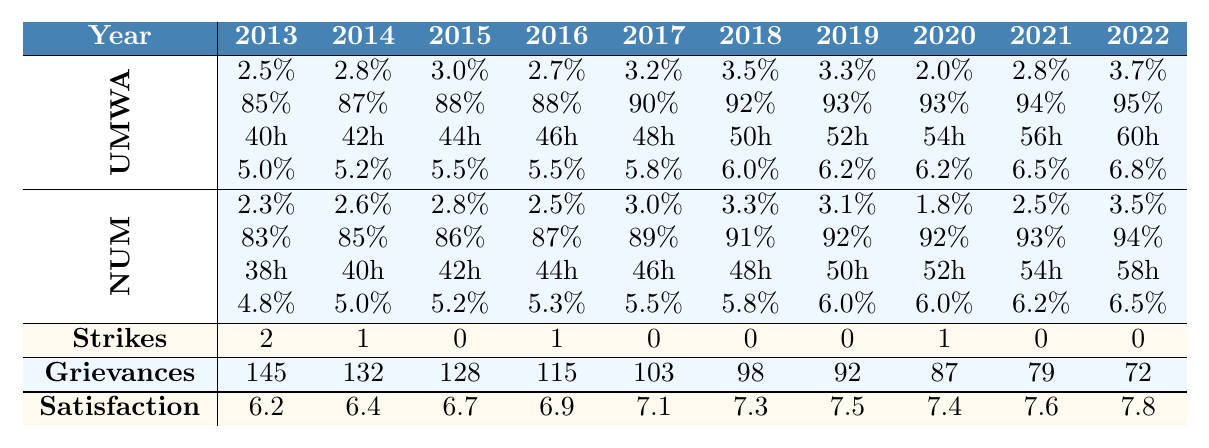What was the highest wage increase percentage from the United Mine Workers of America over the decade? Looking at the UMWA row for "Wage Increase (%)", the highest value appears to be 3.7% in 2022.
Answer: 3.7% How many hours of safety training were implemented in 2015 by the National Union of Mineworkers? The "Safety Training Hours" for NUM in 2015 is listed as 42 hours.
Answer: 42 hours Which year saw the least number of grievances filed? Referring to the "Grievances Filed" row, the least amount is 72 grievances in 2022.
Answer: 72 What is the average wage increase percentage over the decade for the United Mine Workers of America? The wage increase percentages are 2.5, 2.8, 3.0, 2.7, 3.2, 3.5, 3.3, 2.0, 2.8, and 3.7. To find the average, add them all up (28.5) and divide by 10, resulting in 2.85%.
Answer: 2.85% Did the United Mine Workers of America have more wage increases compared to the National Union of Mineworkers from 2013 to 2022? Observing the "Wage Increase (%)" for both unions shows UMWA had higher percentages in most years, with NUM only exceeding UMWA in 2014, 2018, and 2019.
Answer: Yes In which year did the highest worker satisfaction score occur? Looking at the "Worker Satisfaction Score" row, the highest score is 7.8, recorded in 2022.
Answer: 2022 What was the change in healthcare coverage percentage from 2013 to 2022 for the National Union of Mineworkers? The percentage for NUM in 2013 is 83%, and it increased to 94% in 2022. The change is 94% - 83% = 11%.
Answer: 11% How many total strikes occurred from 2013 to 2022? To find the total strikes, add the values from the "Strikes" row: 2 + 1 + 0 + 1 + 0 + 0 + 0 + 1 + 0 + 0, totaling 5 strikes.
Answer: 5 Was there a year without any strikes from the United Mine Workers of America? Checking the "Strikes" row, the years 2015, 2017, 2018, 2021, and 2022 have 0 strikes, meaning there were multiple years without strikes.
Answer: Yes What improvement in worker satisfaction score was observed between 2013 and 2022? The satisfaction score in 2013 was 6.2, which rose to 7.8 in 2022. The improvement is 7.8 - 6.2 = 1.6 points.
Answer: 1.6 points 